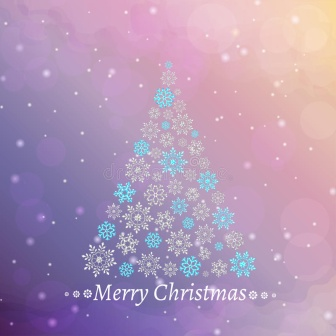What kind of emotions does this Christmas scene evoke for you? This beautiful Christmas scene evokes a sense of calm, joy, and nostalgia. The serene colors and the gentle snowfall create a peaceful and dreamy atmosphere. The elegant inscriptions of 'Merry Christmas' add a touch of warmth and festivity, making one feel the joys and togetherness associated with the holiday season. Do you think this image could be used on a Christmas card? Absolutely! This image would make an excellent Christmas card. Its elegant design and festive aura perfectly capture the spirit of Christmas. The unique snowflake tree and the warm gradient background would undoubtedly bring joy to anyone who receives this card. 